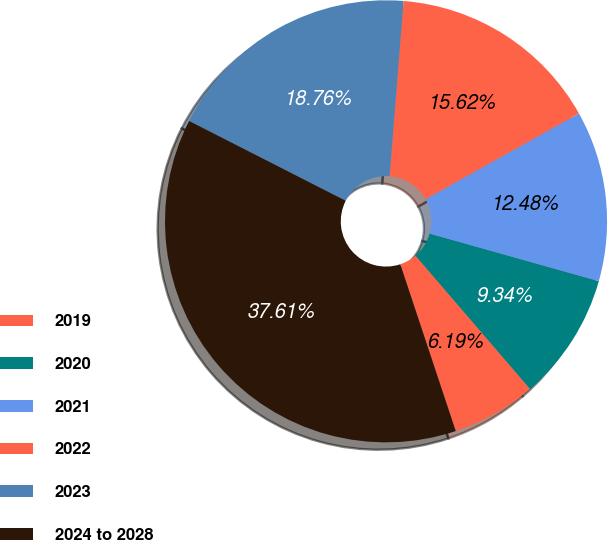Convert chart to OTSL. <chart><loc_0><loc_0><loc_500><loc_500><pie_chart><fcel>2019<fcel>2020<fcel>2021<fcel>2022<fcel>2023<fcel>2024 to 2028<nl><fcel>6.19%<fcel>9.34%<fcel>12.48%<fcel>15.62%<fcel>18.76%<fcel>37.61%<nl></chart> 